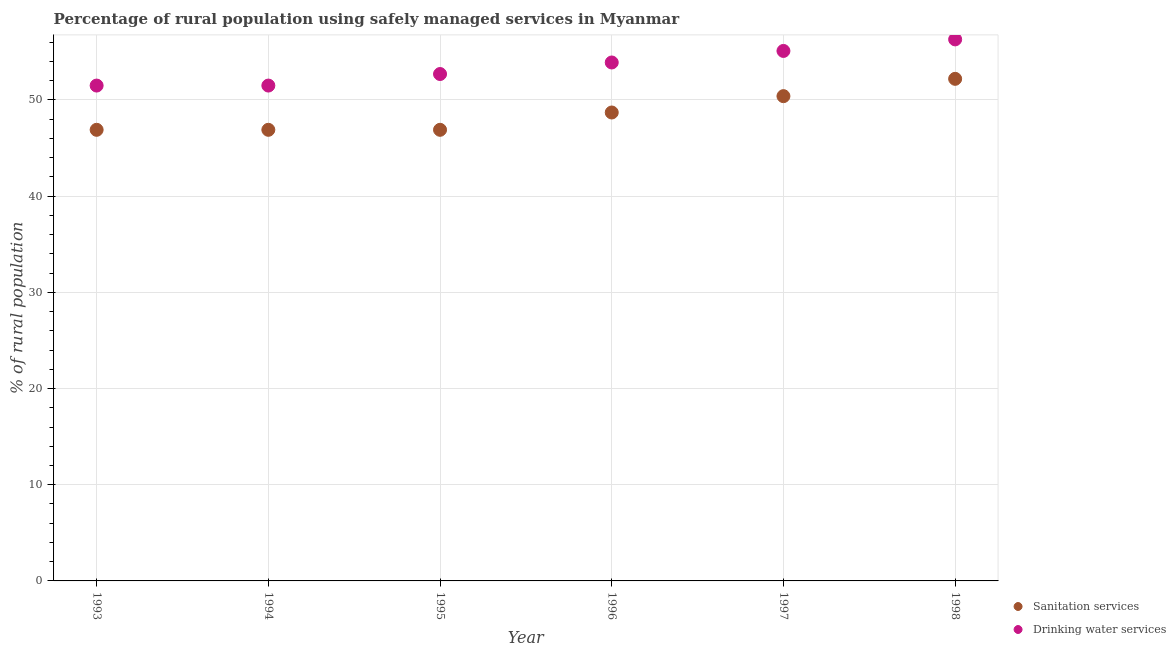What is the percentage of rural population who used sanitation services in 1994?
Offer a terse response. 46.9. Across all years, what is the maximum percentage of rural population who used sanitation services?
Your answer should be very brief. 52.2. Across all years, what is the minimum percentage of rural population who used sanitation services?
Keep it short and to the point. 46.9. In which year was the percentage of rural population who used sanitation services maximum?
Ensure brevity in your answer.  1998. What is the total percentage of rural population who used drinking water services in the graph?
Provide a short and direct response. 321. What is the difference between the percentage of rural population who used drinking water services in 1995 and that in 1997?
Provide a short and direct response. -2.4. What is the difference between the percentage of rural population who used drinking water services in 1994 and the percentage of rural population who used sanitation services in 1996?
Your answer should be compact. 2.8. What is the average percentage of rural population who used drinking water services per year?
Make the answer very short. 53.5. In the year 1998, what is the difference between the percentage of rural population who used sanitation services and percentage of rural population who used drinking water services?
Make the answer very short. -4.1. What is the ratio of the percentage of rural population who used drinking water services in 1995 to that in 1997?
Ensure brevity in your answer.  0.96. Is the percentage of rural population who used sanitation services in 1995 less than that in 1996?
Ensure brevity in your answer.  Yes. Is the difference between the percentage of rural population who used sanitation services in 1996 and 1997 greater than the difference between the percentage of rural population who used drinking water services in 1996 and 1997?
Ensure brevity in your answer.  No. What is the difference between the highest and the second highest percentage of rural population who used drinking water services?
Your answer should be compact. 1.2. What is the difference between the highest and the lowest percentage of rural population who used sanitation services?
Your answer should be very brief. 5.3. Is the percentage of rural population who used sanitation services strictly greater than the percentage of rural population who used drinking water services over the years?
Your response must be concise. No. Is the percentage of rural population who used drinking water services strictly less than the percentage of rural population who used sanitation services over the years?
Offer a terse response. No. How many years are there in the graph?
Provide a succinct answer. 6. What is the difference between two consecutive major ticks on the Y-axis?
Make the answer very short. 10. Are the values on the major ticks of Y-axis written in scientific E-notation?
Your answer should be very brief. No. Does the graph contain any zero values?
Your answer should be compact. No. How are the legend labels stacked?
Provide a succinct answer. Vertical. What is the title of the graph?
Make the answer very short. Percentage of rural population using safely managed services in Myanmar. What is the label or title of the Y-axis?
Provide a succinct answer. % of rural population. What is the % of rural population in Sanitation services in 1993?
Your response must be concise. 46.9. What is the % of rural population of Drinking water services in 1993?
Provide a succinct answer. 51.5. What is the % of rural population of Sanitation services in 1994?
Your response must be concise. 46.9. What is the % of rural population of Drinking water services in 1994?
Provide a short and direct response. 51.5. What is the % of rural population in Sanitation services in 1995?
Give a very brief answer. 46.9. What is the % of rural population of Drinking water services in 1995?
Keep it short and to the point. 52.7. What is the % of rural population of Sanitation services in 1996?
Give a very brief answer. 48.7. What is the % of rural population of Drinking water services in 1996?
Give a very brief answer. 53.9. What is the % of rural population in Sanitation services in 1997?
Your response must be concise. 50.4. What is the % of rural population in Drinking water services in 1997?
Provide a short and direct response. 55.1. What is the % of rural population of Sanitation services in 1998?
Give a very brief answer. 52.2. What is the % of rural population of Drinking water services in 1998?
Offer a terse response. 56.3. Across all years, what is the maximum % of rural population in Sanitation services?
Your answer should be compact. 52.2. Across all years, what is the maximum % of rural population of Drinking water services?
Offer a very short reply. 56.3. Across all years, what is the minimum % of rural population in Sanitation services?
Your answer should be very brief. 46.9. Across all years, what is the minimum % of rural population of Drinking water services?
Offer a terse response. 51.5. What is the total % of rural population of Sanitation services in the graph?
Your answer should be compact. 292. What is the total % of rural population of Drinking water services in the graph?
Make the answer very short. 321. What is the difference between the % of rural population of Drinking water services in 1993 and that in 1994?
Give a very brief answer. 0. What is the difference between the % of rural population in Sanitation services in 1993 and that in 1997?
Your response must be concise. -3.5. What is the difference between the % of rural population of Drinking water services in 1993 and that in 1997?
Keep it short and to the point. -3.6. What is the difference between the % of rural population of Drinking water services in 1993 and that in 1998?
Offer a very short reply. -4.8. What is the difference between the % of rural population in Sanitation services in 1994 and that in 1995?
Give a very brief answer. 0. What is the difference between the % of rural population of Drinking water services in 1994 and that in 1995?
Your response must be concise. -1.2. What is the difference between the % of rural population of Drinking water services in 1994 and that in 1996?
Your response must be concise. -2.4. What is the difference between the % of rural population of Sanitation services in 1994 and that in 1997?
Offer a very short reply. -3.5. What is the difference between the % of rural population in Sanitation services in 1995 and that in 1996?
Give a very brief answer. -1.8. What is the difference between the % of rural population in Drinking water services in 1995 and that in 1996?
Make the answer very short. -1.2. What is the difference between the % of rural population of Drinking water services in 1995 and that in 1997?
Provide a succinct answer. -2.4. What is the difference between the % of rural population in Sanitation services in 1995 and that in 1998?
Keep it short and to the point. -5.3. What is the difference between the % of rural population in Drinking water services in 1996 and that in 1998?
Make the answer very short. -2.4. What is the difference between the % of rural population of Sanitation services in 1997 and that in 1998?
Offer a very short reply. -1.8. What is the difference between the % of rural population of Sanitation services in 1993 and the % of rural population of Drinking water services in 1994?
Provide a short and direct response. -4.6. What is the difference between the % of rural population of Sanitation services in 1993 and the % of rural population of Drinking water services in 1995?
Give a very brief answer. -5.8. What is the difference between the % of rural population of Sanitation services in 1993 and the % of rural population of Drinking water services in 1996?
Your answer should be compact. -7. What is the difference between the % of rural population of Sanitation services in 1993 and the % of rural population of Drinking water services in 1998?
Make the answer very short. -9.4. What is the difference between the % of rural population of Sanitation services in 1994 and the % of rural population of Drinking water services in 1997?
Your answer should be compact. -8.2. What is the difference between the % of rural population in Sanitation services in 1995 and the % of rural population in Drinking water services in 1997?
Make the answer very short. -8.2. What is the difference between the % of rural population in Sanitation services in 1995 and the % of rural population in Drinking water services in 1998?
Your response must be concise. -9.4. What is the difference between the % of rural population in Sanitation services in 1996 and the % of rural population in Drinking water services in 1997?
Provide a short and direct response. -6.4. What is the difference between the % of rural population in Sanitation services in 1996 and the % of rural population in Drinking water services in 1998?
Give a very brief answer. -7.6. What is the difference between the % of rural population of Sanitation services in 1997 and the % of rural population of Drinking water services in 1998?
Provide a short and direct response. -5.9. What is the average % of rural population of Sanitation services per year?
Keep it short and to the point. 48.67. What is the average % of rural population in Drinking water services per year?
Your response must be concise. 53.5. In the year 1993, what is the difference between the % of rural population in Sanitation services and % of rural population in Drinking water services?
Make the answer very short. -4.6. In the year 1995, what is the difference between the % of rural population in Sanitation services and % of rural population in Drinking water services?
Make the answer very short. -5.8. In the year 1996, what is the difference between the % of rural population of Sanitation services and % of rural population of Drinking water services?
Give a very brief answer. -5.2. In the year 1998, what is the difference between the % of rural population in Sanitation services and % of rural population in Drinking water services?
Give a very brief answer. -4.1. What is the ratio of the % of rural population in Sanitation services in 1993 to that in 1994?
Provide a succinct answer. 1. What is the ratio of the % of rural population of Sanitation services in 1993 to that in 1995?
Your answer should be compact. 1. What is the ratio of the % of rural population in Drinking water services in 1993 to that in 1995?
Make the answer very short. 0.98. What is the ratio of the % of rural population in Drinking water services in 1993 to that in 1996?
Offer a very short reply. 0.96. What is the ratio of the % of rural population of Sanitation services in 1993 to that in 1997?
Your answer should be very brief. 0.93. What is the ratio of the % of rural population in Drinking water services in 1993 to that in 1997?
Offer a very short reply. 0.93. What is the ratio of the % of rural population of Sanitation services in 1993 to that in 1998?
Keep it short and to the point. 0.9. What is the ratio of the % of rural population of Drinking water services in 1993 to that in 1998?
Keep it short and to the point. 0.91. What is the ratio of the % of rural population of Sanitation services in 1994 to that in 1995?
Your response must be concise. 1. What is the ratio of the % of rural population of Drinking water services in 1994 to that in 1995?
Give a very brief answer. 0.98. What is the ratio of the % of rural population in Sanitation services in 1994 to that in 1996?
Provide a short and direct response. 0.96. What is the ratio of the % of rural population of Drinking water services in 1994 to that in 1996?
Offer a terse response. 0.96. What is the ratio of the % of rural population of Sanitation services in 1994 to that in 1997?
Offer a very short reply. 0.93. What is the ratio of the % of rural population of Drinking water services in 1994 to that in 1997?
Provide a short and direct response. 0.93. What is the ratio of the % of rural population in Sanitation services in 1994 to that in 1998?
Offer a terse response. 0.9. What is the ratio of the % of rural population of Drinking water services in 1994 to that in 1998?
Provide a succinct answer. 0.91. What is the ratio of the % of rural population in Sanitation services in 1995 to that in 1996?
Keep it short and to the point. 0.96. What is the ratio of the % of rural population of Drinking water services in 1995 to that in 1996?
Offer a terse response. 0.98. What is the ratio of the % of rural population in Sanitation services in 1995 to that in 1997?
Give a very brief answer. 0.93. What is the ratio of the % of rural population of Drinking water services in 1995 to that in 1997?
Your answer should be very brief. 0.96. What is the ratio of the % of rural population of Sanitation services in 1995 to that in 1998?
Your answer should be compact. 0.9. What is the ratio of the % of rural population in Drinking water services in 1995 to that in 1998?
Your response must be concise. 0.94. What is the ratio of the % of rural population in Sanitation services in 1996 to that in 1997?
Provide a short and direct response. 0.97. What is the ratio of the % of rural population of Drinking water services in 1996 to that in 1997?
Your answer should be very brief. 0.98. What is the ratio of the % of rural population of Sanitation services in 1996 to that in 1998?
Provide a short and direct response. 0.93. What is the ratio of the % of rural population in Drinking water services in 1996 to that in 1998?
Provide a succinct answer. 0.96. What is the ratio of the % of rural population in Sanitation services in 1997 to that in 1998?
Your answer should be compact. 0.97. What is the ratio of the % of rural population in Drinking water services in 1997 to that in 1998?
Offer a terse response. 0.98. What is the difference between the highest and the lowest % of rural population of Drinking water services?
Provide a succinct answer. 4.8. 